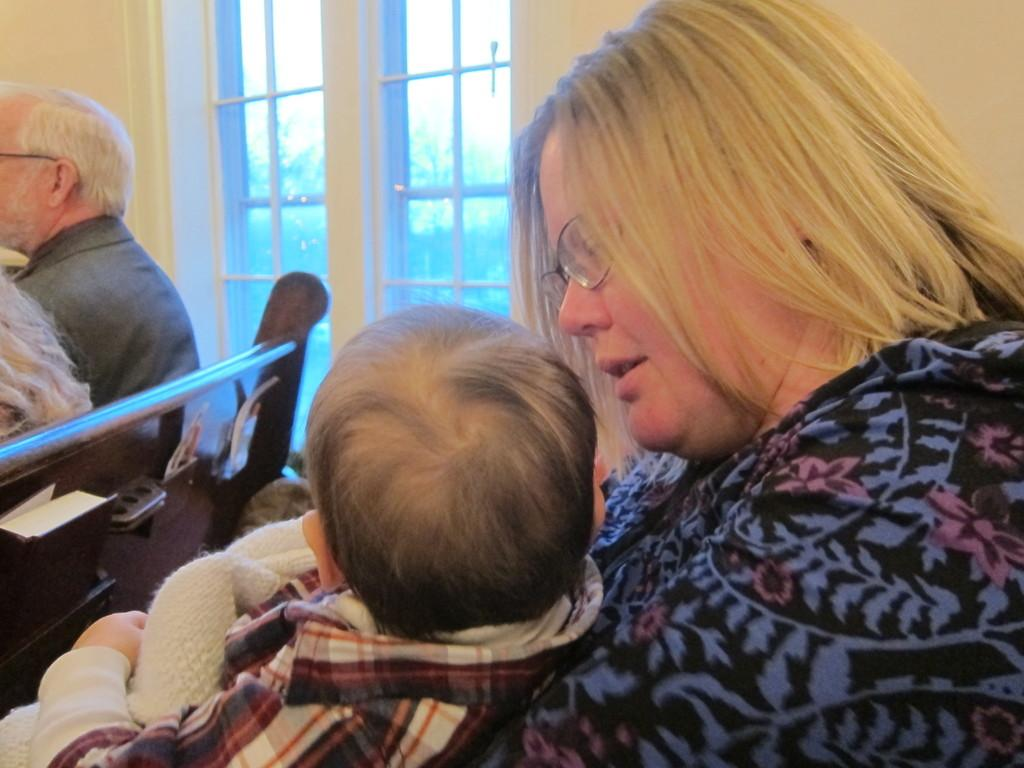What is the woman doing in the image? The woman is holding a baby in the image. What is the man doing in the image? The man is sitting on a bench in the image. What can be seen in the background of the image? There is a wall and a glass door in the background of the image. What type of dinner is being served in the image? There is no dinner present in the image. What does the goat smell like in the image? There is no goat present in the image, so it cannot be determined what it might smell like. 